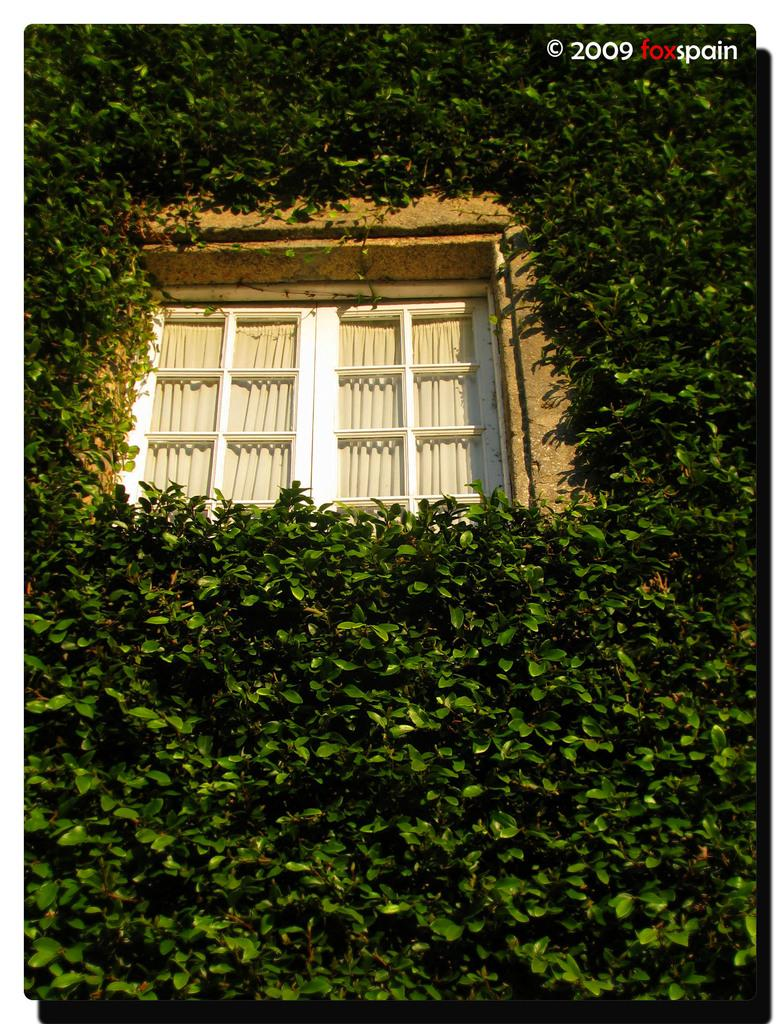What is a prominent feature of the image? There is a wall in the image. What is attached to the wall? The wall has curtains. Is there any opening in the wall? Yes, there is a window in the wall. What can be seen outside the window? Leaves are present in the image. Is there any indication of the image's origin or ownership? The image has a watermark. What type of humor can be seen in the image? There is no humor present in the image; it features a wall with curtains, a window, and leaves outside. Can you tell me how many basketballs are visible in the image? There are no basketballs present in the image. 